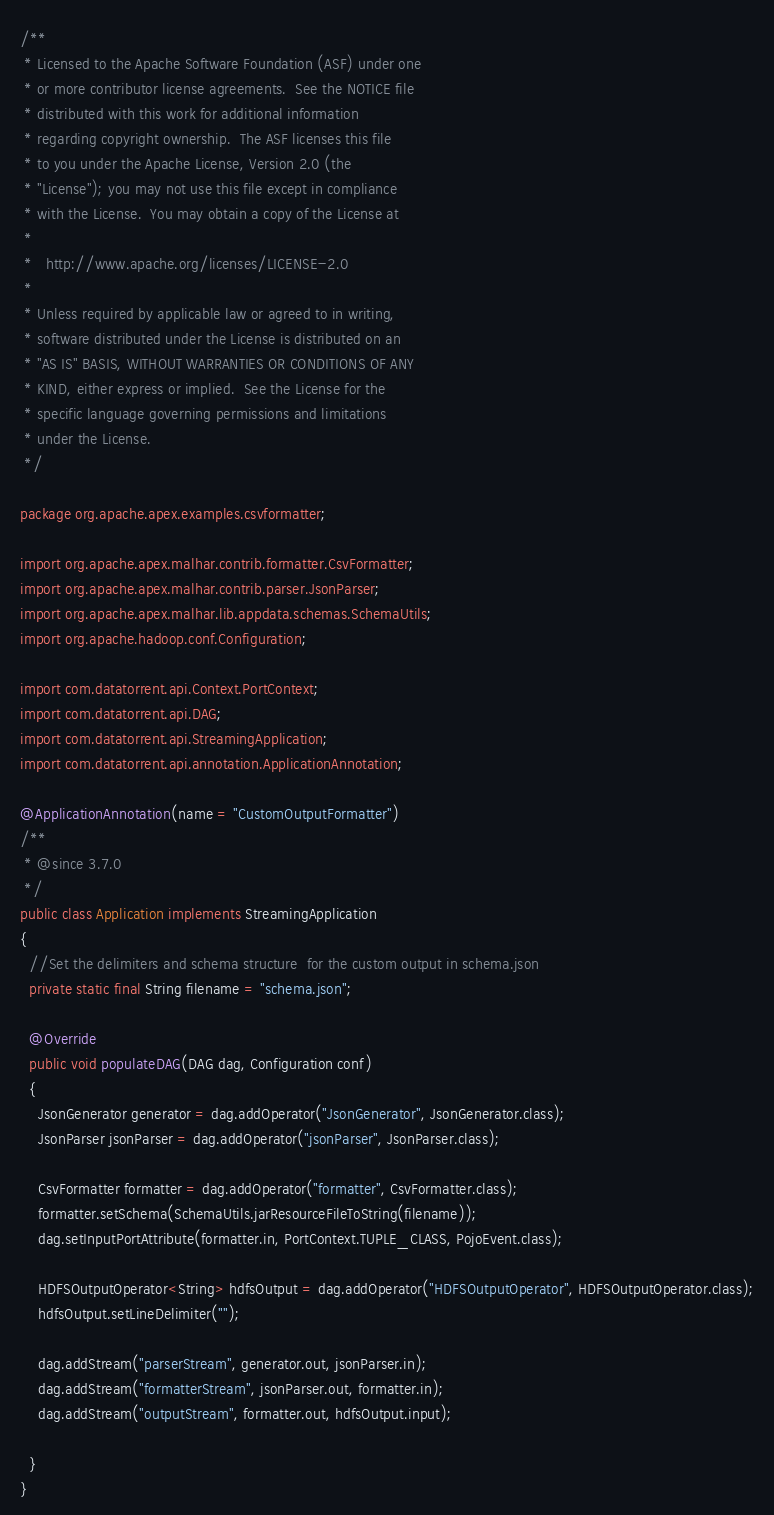Convert code to text. <code><loc_0><loc_0><loc_500><loc_500><_Java_>/**
 * Licensed to the Apache Software Foundation (ASF) under one
 * or more contributor license agreements.  See the NOTICE file
 * distributed with this work for additional information
 * regarding copyright ownership.  The ASF licenses this file
 * to you under the Apache License, Version 2.0 (the
 * "License"); you may not use this file except in compliance
 * with the License.  You may obtain a copy of the License at
 *
 *   http://www.apache.org/licenses/LICENSE-2.0
 *
 * Unless required by applicable law or agreed to in writing,
 * software distributed under the License is distributed on an
 * "AS IS" BASIS, WITHOUT WARRANTIES OR CONDITIONS OF ANY
 * KIND, either express or implied.  See the License for the
 * specific language governing permissions and limitations
 * under the License.
 */

package org.apache.apex.examples.csvformatter;

import org.apache.apex.malhar.contrib.formatter.CsvFormatter;
import org.apache.apex.malhar.contrib.parser.JsonParser;
import org.apache.apex.malhar.lib.appdata.schemas.SchemaUtils;
import org.apache.hadoop.conf.Configuration;

import com.datatorrent.api.Context.PortContext;
import com.datatorrent.api.DAG;
import com.datatorrent.api.StreamingApplication;
import com.datatorrent.api.annotation.ApplicationAnnotation;

@ApplicationAnnotation(name = "CustomOutputFormatter")
/**
 * @since 3.7.0
 */
public class Application implements StreamingApplication
{
  //Set the delimiters and schema structure  for the custom output in schema.json
  private static final String filename = "schema.json";

  @Override
  public void populateDAG(DAG dag, Configuration conf)
  {
    JsonGenerator generator = dag.addOperator("JsonGenerator", JsonGenerator.class);
    JsonParser jsonParser = dag.addOperator("jsonParser", JsonParser.class);

    CsvFormatter formatter = dag.addOperator("formatter", CsvFormatter.class);
    formatter.setSchema(SchemaUtils.jarResourceFileToString(filename));
    dag.setInputPortAttribute(formatter.in, PortContext.TUPLE_CLASS, PojoEvent.class);

    HDFSOutputOperator<String> hdfsOutput = dag.addOperator("HDFSOutputOperator", HDFSOutputOperator.class);
    hdfsOutput.setLineDelimiter("");

    dag.addStream("parserStream", generator.out, jsonParser.in);
    dag.addStream("formatterStream", jsonParser.out, formatter.in);
    dag.addStream("outputStream", formatter.out, hdfsOutput.input);

  }
}
</code> 